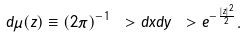Convert formula to latex. <formula><loc_0><loc_0><loc_500><loc_500>d \mu ( z ) \equiv ( 2 \pi ) ^ { - 1 } \ > d x d y \ > e ^ { - \frac { | z | ^ { 2 } } { 2 } } .</formula> 